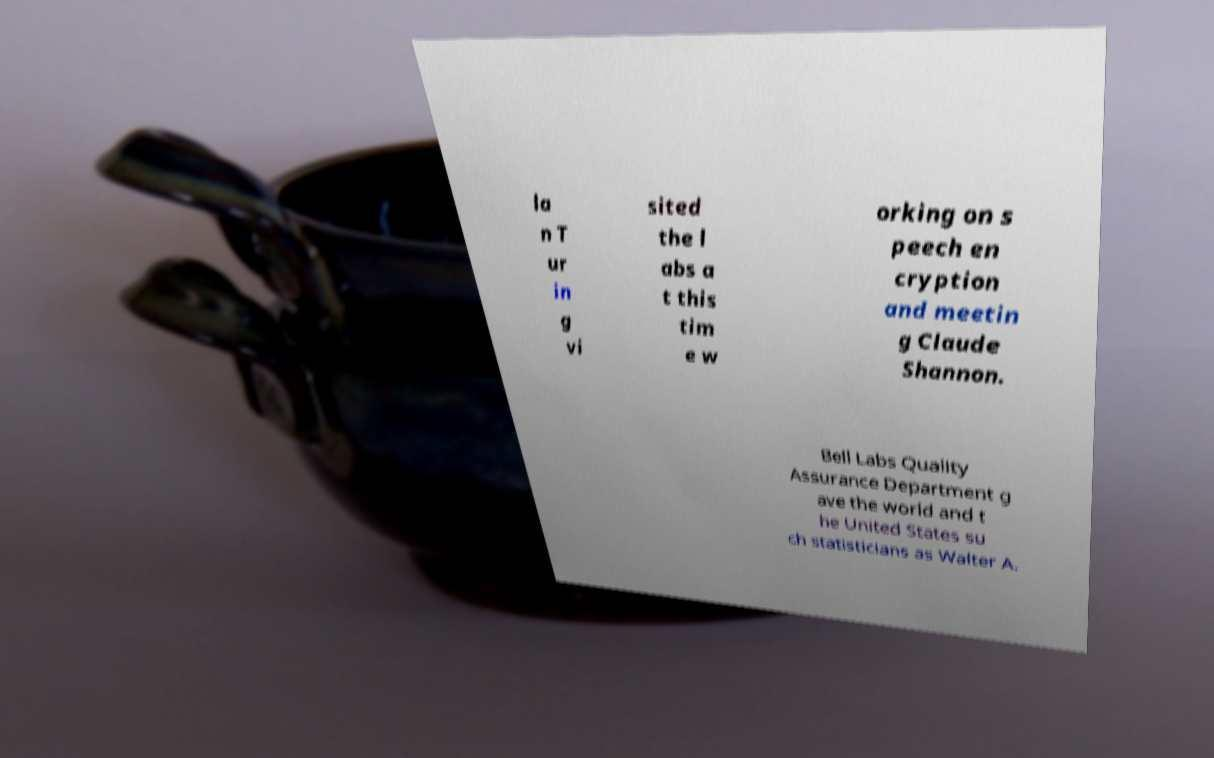Could you assist in decoding the text presented in this image and type it out clearly? la n T ur in g vi sited the l abs a t this tim e w orking on s peech en cryption and meetin g Claude Shannon. Bell Labs Quality Assurance Department g ave the world and t he United States su ch statisticians as Walter A. 